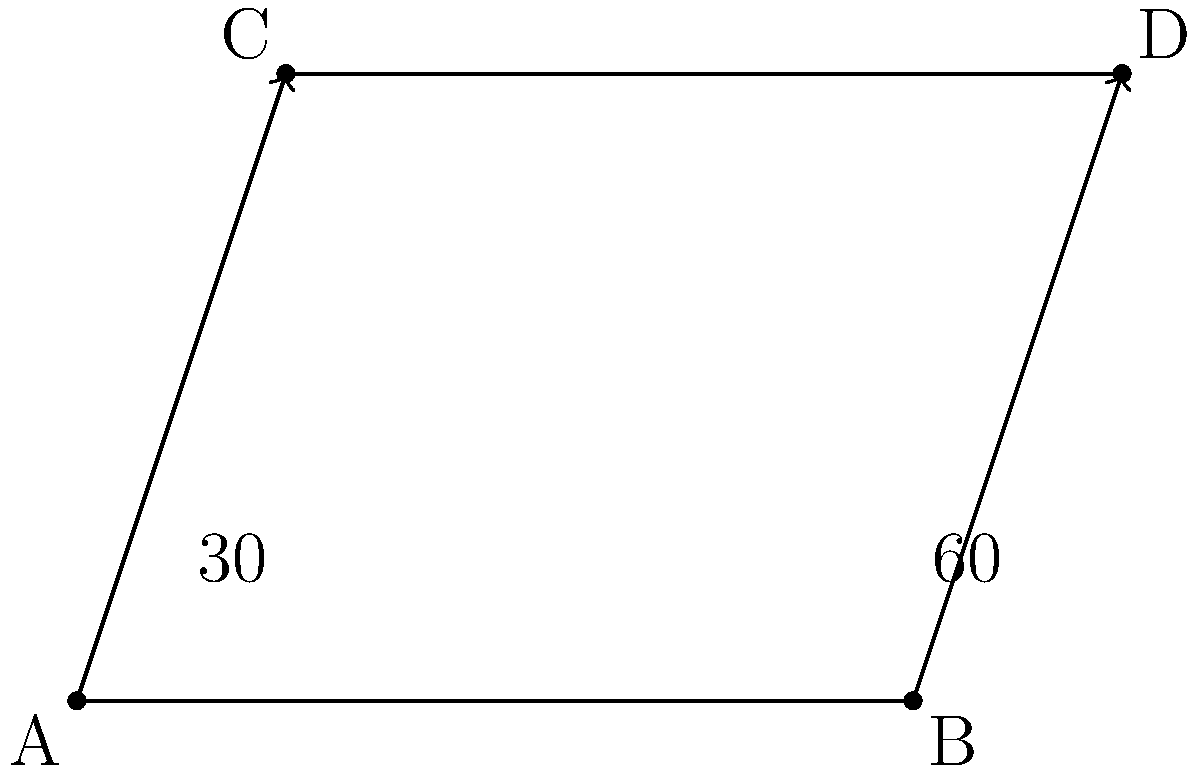In the diagram, two lines intersect at point P (not shown). Line AC forms a 30° angle with the horizontal, while line BD forms a 60° angle with the horizontal. Calculate the acute angle between these two intersecting lines. To find the acute angle between the two intersecting lines, we can follow these steps:

1) The angle between two lines is the absolute difference between their individual angles with respect to a common reference line. In this case, we'll use the horizontal line as our reference.

2) We're given that:
   - Line AC forms a 30° angle with the horizontal
   - Line BD forms a 60° angle with the horizontal

3) The acute angle between the lines is:
   $$|\text{Angle of BD} - \text{Angle of AC}| = |60° - 30°| = 30°$$

4) We take the absolute value because we're interested in the acute angle, which is always positive and less than or equal to 90°.

This approach aligns with the trigonometric principle that the angle between two lines can be found by subtracting their individual angles from a common reference line. It's a practical application of angle relationships in intersecting lines, which is a fundamental concept in mechatronics and robotics for understanding spatial relationships and motion planning.
Answer: 30° 